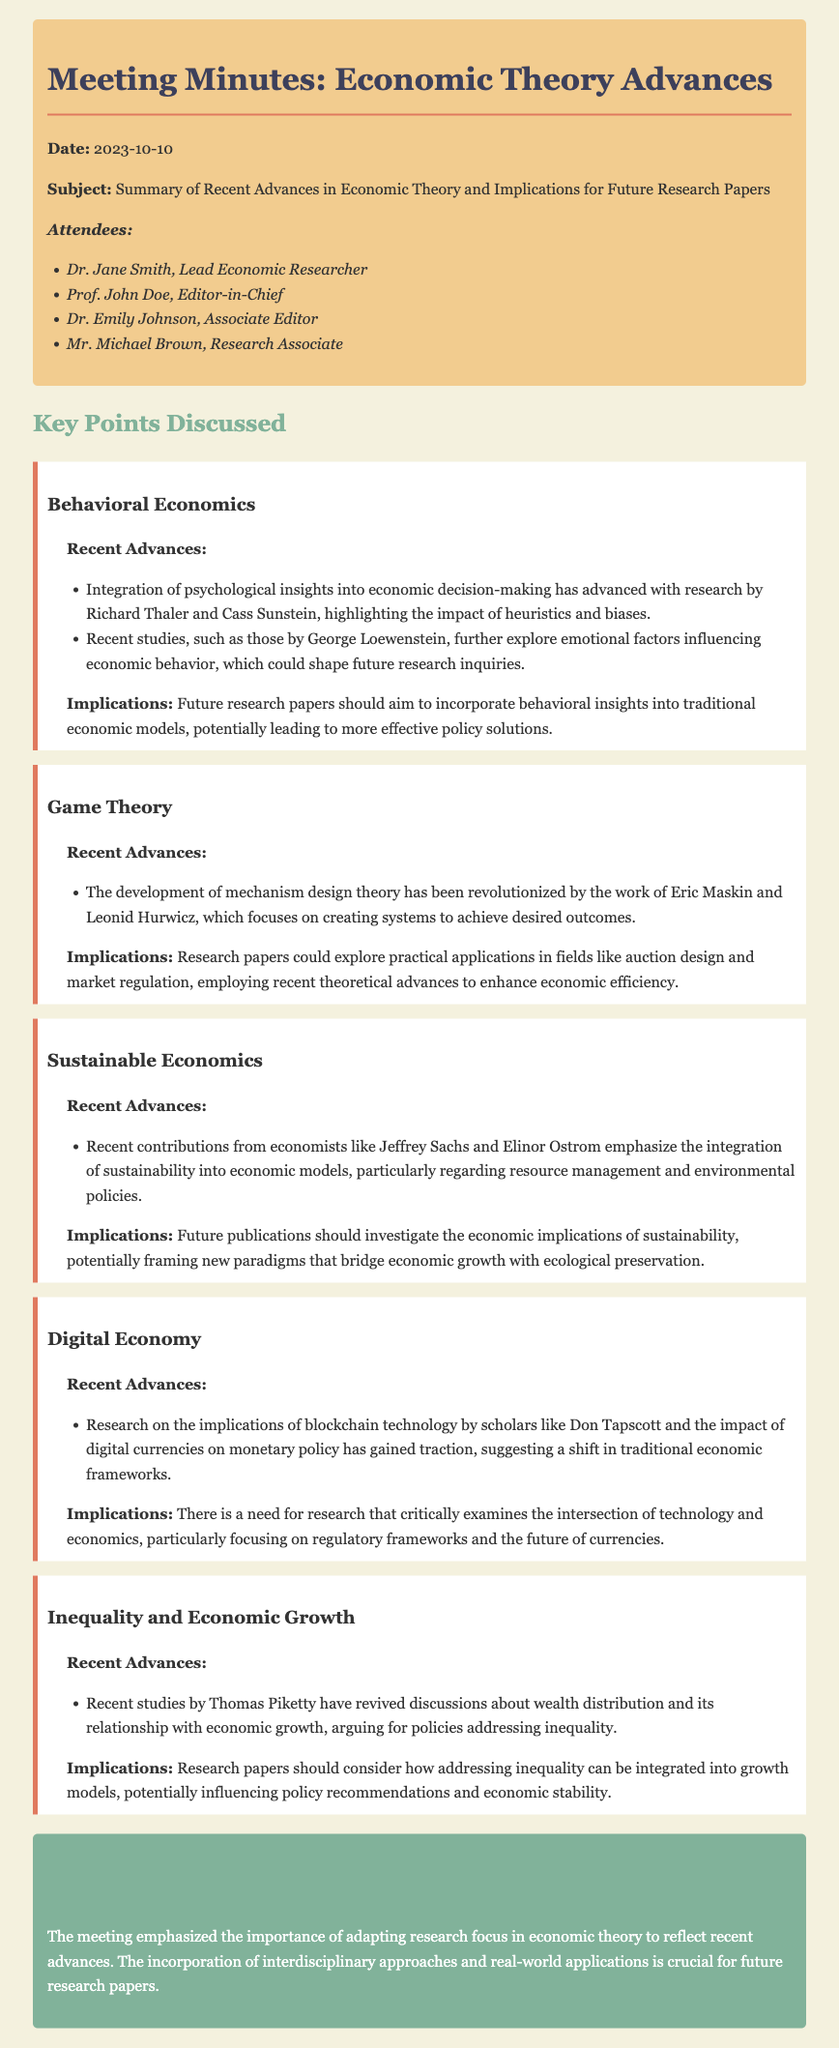What is the date of the meeting? The date of the meeting is mentioned in the header section of the document.
Answer: 2023-10-10 Who is the Lead Economic Researcher? The document lists the attendees, including the Lead Economic Researcher.
Answer: Dr. Jane Smith What key advance is associated with Behavioral Economics? The document highlights recent advances in Behavioral Economics, specifically mentioning relevant researchers.
Answer: Integration of psychological insights What is one implication of Game Theory discussed in the meeting? The implications of Game Theory can be found in the respective section of the document.
Answer: Practical applications in auction design Which economist is noted for recent studies on wealth distribution? The document mentions a specific economist in relation to studies on inequality and economic growth.
Answer: Thomas Piketty What is a recent topic of research in the Digital Economy? The document specifies recent research areas related to the Digital Economy within that section.
Answer: Implications of blockchain technology What is emphasized as a necessary focus for future research papers? The conclusion summarizes the overall emphasis from the meeting regarding future research.
Answer: Incorporation of interdisciplinary approaches Which concept is associated with Sustainable Economics? The advances in Sustainable Economics section mentions key contributions regarding economic models.
Answer: Integration of sustainability How many attendees were present at the meeting? The document lists the attendees at the beginning, allowing for a count of individuals present.
Answer: Four 